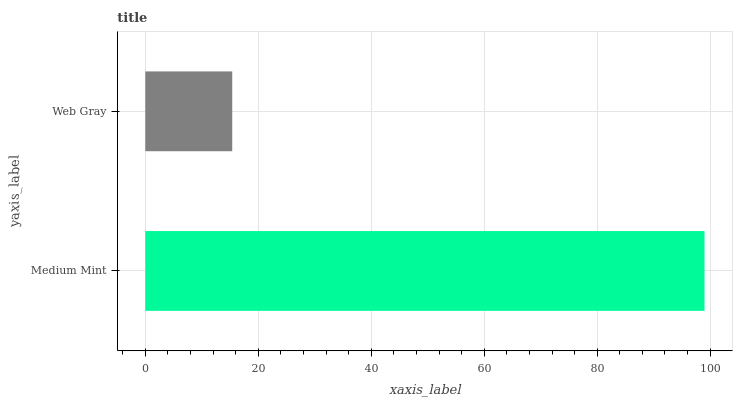Is Web Gray the minimum?
Answer yes or no. Yes. Is Medium Mint the maximum?
Answer yes or no. Yes. Is Web Gray the maximum?
Answer yes or no. No. Is Medium Mint greater than Web Gray?
Answer yes or no. Yes. Is Web Gray less than Medium Mint?
Answer yes or no. Yes. Is Web Gray greater than Medium Mint?
Answer yes or no. No. Is Medium Mint less than Web Gray?
Answer yes or no. No. Is Medium Mint the high median?
Answer yes or no. Yes. Is Web Gray the low median?
Answer yes or no. Yes. Is Web Gray the high median?
Answer yes or no. No. Is Medium Mint the low median?
Answer yes or no. No. 